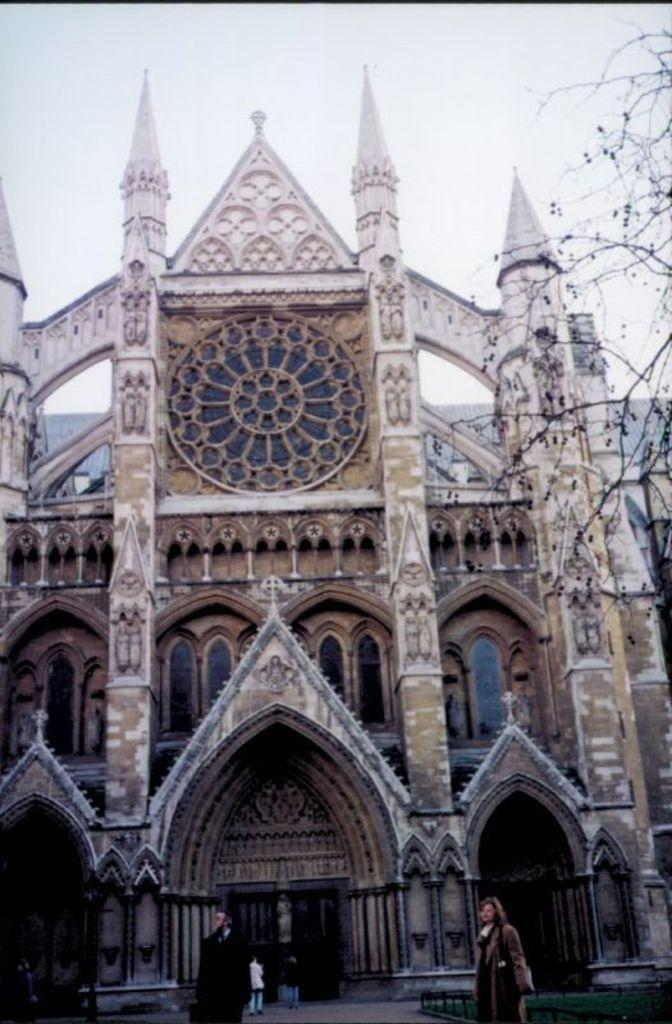What type of natural element is present in the image? There is a tree in the image. What type of structure can be seen in the image? There is a building with windows in the image. What are the people in the image doing? There are persons standing on the ground in the image. What is visible in the background of the image? The sky is visible in the background of the image. What grade of tin is used to make the building in the image? There is no mention of tin or its grade in the image; the building has windows. What type of skin can be seen on the persons standing on the ground in the image? There is no information about the skin of the persons in the image, as we cannot see their skin from the provided facts. 